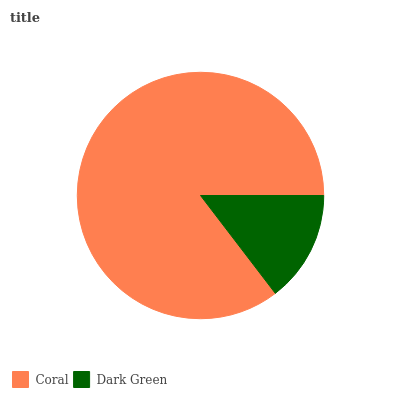Is Dark Green the minimum?
Answer yes or no. Yes. Is Coral the maximum?
Answer yes or no. Yes. Is Dark Green the maximum?
Answer yes or no. No. Is Coral greater than Dark Green?
Answer yes or no. Yes. Is Dark Green less than Coral?
Answer yes or no. Yes. Is Dark Green greater than Coral?
Answer yes or no. No. Is Coral less than Dark Green?
Answer yes or no. No. Is Coral the high median?
Answer yes or no. Yes. Is Dark Green the low median?
Answer yes or no. Yes. Is Dark Green the high median?
Answer yes or no. No. Is Coral the low median?
Answer yes or no. No. 